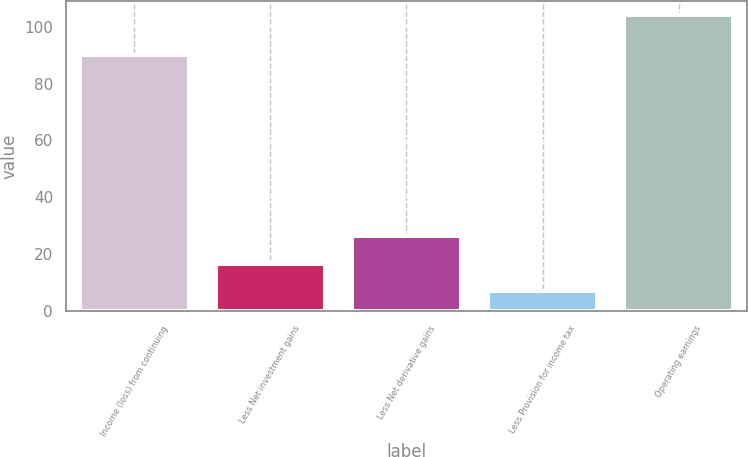<chart> <loc_0><loc_0><loc_500><loc_500><bar_chart><fcel>Income (loss) from continuing<fcel>Less Net investment gains<fcel>Less Net derivative gains<fcel>Less Provision for income tax<fcel>Operating earnings<nl><fcel>90<fcel>16.7<fcel>26.4<fcel>7<fcel>104<nl></chart> 